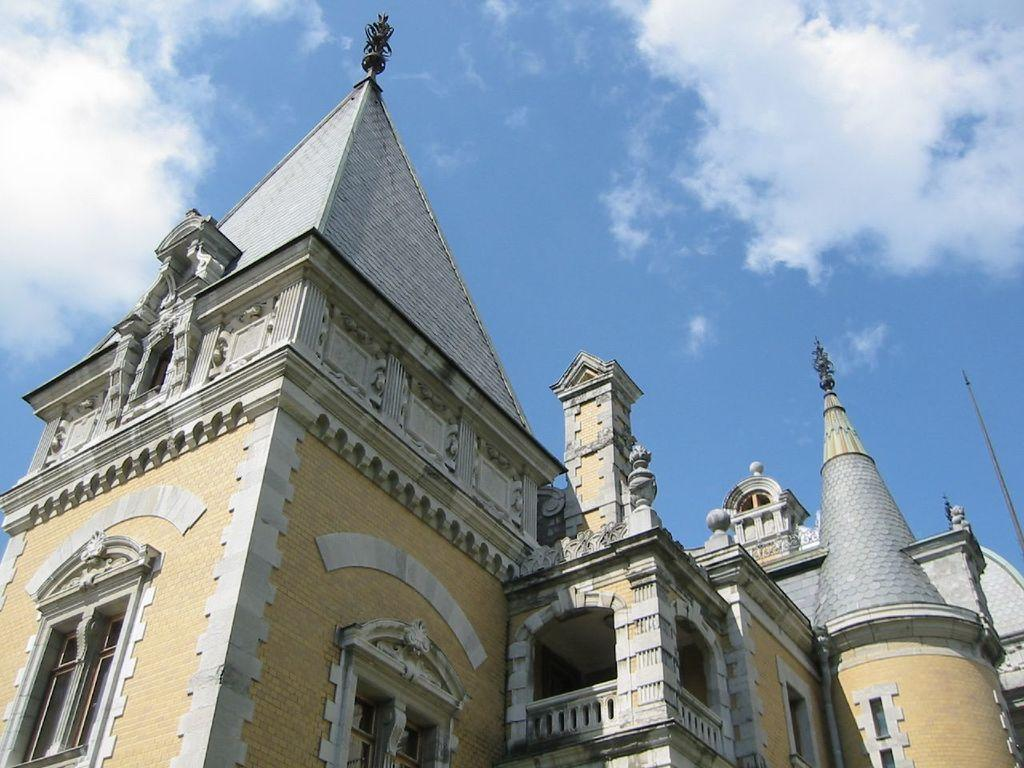What is the main subject of the picture? The main subject of the picture is a building. What specific features can be observed on the building? The building has windows. What else can be seen in the picture besides the building? There are other objects in the picture. What is visible in the background of the picture? The sky is visible in the background of the picture. What type of books can be heard being read aloud in the picture? There is no mention of books or any audible activity in the picture, so it is not possible to determine if any books are being read aloud. Can you see a kettle on the building in the picture? There is no kettle visible in the picture; the image only shows a building with windows and other unspecified objects. 